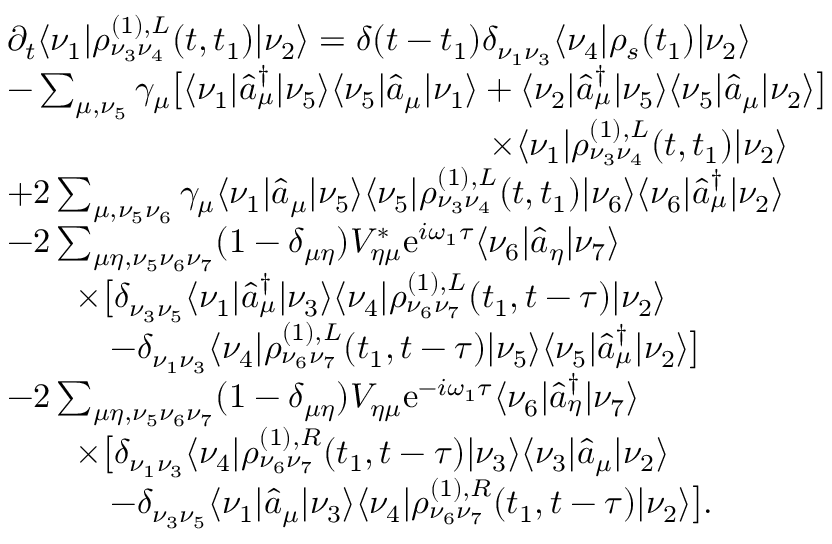<formula> <loc_0><loc_0><loc_500><loc_500>\begin{array} { r l } & { \partial _ { t } \langle \nu _ { 1 } | \rho _ { \nu _ { 3 } \nu _ { 4 } } ^ { ( 1 ) , L } ( t , t _ { 1 } ) | \nu _ { 2 } \rangle = \delta ( t - t _ { 1 } ) \delta _ { \nu _ { 1 } \nu _ { 3 } } \langle \nu _ { 4 } | \rho _ { s } ( t _ { 1 } ) | \nu _ { 2 } \rangle } \\ & { - \sum _ { \mu , \nu _ { 5 } } \gamma _ { \mu } \left [ \langle \nu _ { 1 } | \hat { a } _ { \mu } ^ { \dagger } | \nu _ { 5 } \rangle \langle \nu _ { 5 } | \hat { a } _ { \mu } | \nu _ { 1 } \rangle + \langle \nu _ { 2 } | \hat { a } _ { \mu } ^ { \dagger } | \nu _ { 5 } \rangle \langle \nu _ { 5 } | \hat { a } _ { \mu } | \nu _ { 2 } \rangle \right ] } \\ & { \quad \times \langle \nu _ { 1 } | \rho _ { \nu _ { 3 } \nu _ { 4 } } ^ { ( 1 ) , L } ( t , t _ { 1 } ) | \nu _ { 2 } \rangle } \\ & { + 2 \sum _ { \mu , \nu _ { 5 } \nu _ { 6 } } \gamma _ { \mu } \langle \nu _ { 1 } | \hat { a } _ { \mu } | \nu _ { 5 } \rangle \langle \nu _ { 5 } | \rho _ { \nu _ { 3 } \nu _ { 4 } } ^ { ( 1 ) , L } ( t , t _ { 1 } ) | \nu _ { 6 } \rangle \langle \nu _ { 6 } | \hat { a } _ { \mu } ^ { \dagger } | \nu _ { 2 } \rangle } \\ & { - 2 \sum _ { \mu \eta , \nu _ { 5 } \nu _ { 6 } \nu _ { 7 } } ( 1 - \delta _ { \mu \eta } ) V _ { \eta \mu } ^ { * } e ^ { i \omega _ { 1 } \tau } \langle \nu _ { 6 } | \hat { a } _ { \eta } | \nu _ { 7 } \rangle } \\ & { \quad \times \left [ \delta _ { \nu _ { 3 } \nu _ { 5 } } \langle \nu _ { 1 } | \hat { a } _ { \mu } ^ { \dagger } | \nu _ { 3 } \rangle \langle \nu _ { 4 } | \rho _ { \nu _ { 6 } \nu _ { 7 } } ^ { ( 1 ) , L } ( t _ { 1 } , t - \tau ) | \nu _ { 2 } \rangle } \\ & { \quad - \delta _ { \nu _ { 1 } \nu _ { 3 } } \langle \nu _ { 4 } | \rho _ { \nu _ { 6 } \nu _ { 7 } } ^ { ( 1 ) , L } ( t _ { 1 } , t - \tau ) | \nu _ { 5 } \rangle \langle \nu _ { 5 } | \hat { a } _ { \mu } ^ { \dagger } | \nu _ { 2 } \rangle \right ] } \\ & { - 2 \sum _ { \mu \eta , \nu _ { 5 } \nu _ { 6 } \nu _ { 7 } } ( 1 - \delta _ { \mu \eta } ) V _ { \eta \mu } e ^ { - i \omega _ { 1 } \tau } \langle \nu _ { 6 } | \hat { a } _ { \eta } ^ { \dagger } | \nu _ { 7 } \rangle } \\ & { \quad \times \left [ \delta _ { \nu _ { 1 } \nu _ { 3 } } \langle \nu _ { 4 } | \rho _ { \nu _ { 6 } \nu _ { 7 } } ^ { ( 1 ) , R } ( t _ { 1 } , t - \tau ) | \nu _ { 3 } \rangle \langle \nu _ { 3 } | \hat { a } _ { \mu } | \nu _ { 2 } \rangle } \\ & { \quad - \delta _ { \nu _ { 3 } \nu _ { 5 } } \langle \nu _ { 1 } | \hat { a } _ { \mu } | \nu _ { 3 } \rangle \langle \nu _ { 4 } | \rho _ { \nu _ { 6 } \nu _ { 7 } } ^ { ( 1 ) , R } ( t _ { 1 } , t - \tau ) | \nu _ { 2 } \rangle \right ] . } \end{array}</formula> 